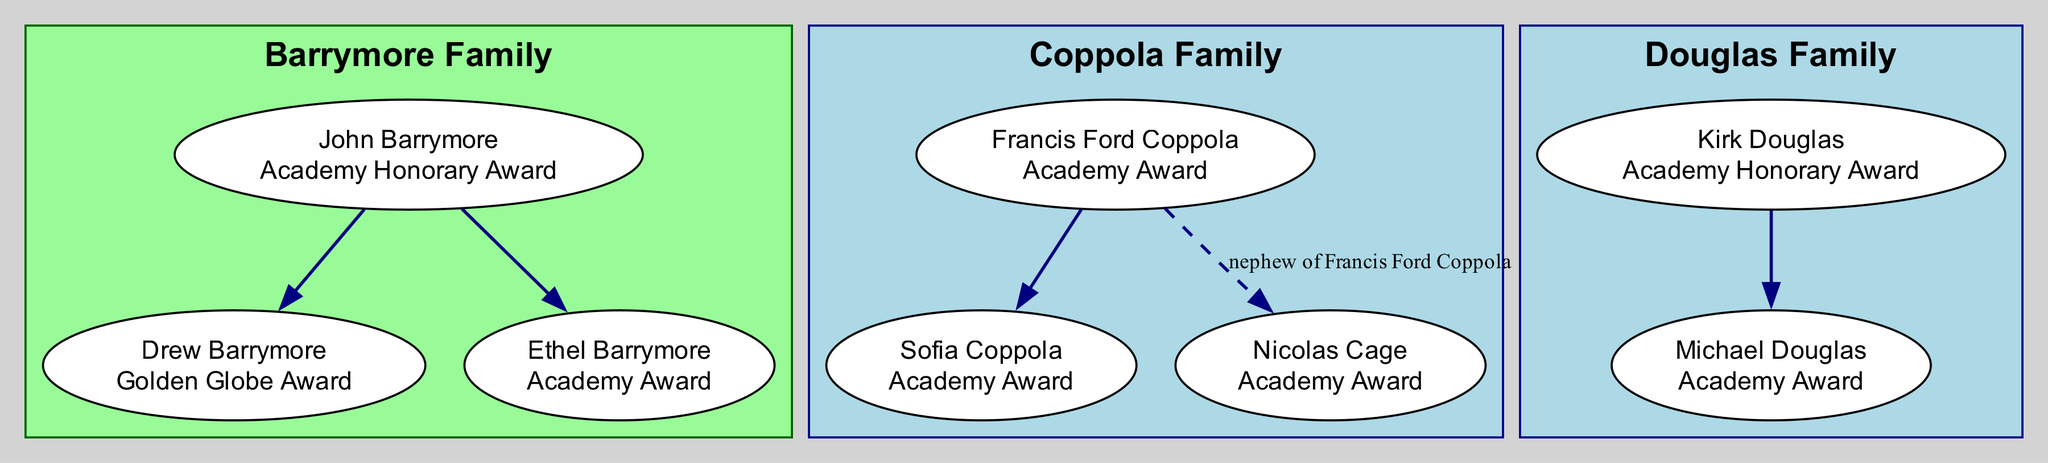What is the award of John Barrymore? The diagram shows a label for John Barrymore which indicates he received an Academy Honorary Award.
Answer: Academy Honorary Award How many generations are in the Barrymore Family? The diagram contains only one level of members under the Barrymore Family; therefore, there are three members listed on the same generation level.
Answer: 1 Who is the parent of Drew Barrymore? Looking at the diagram, it shows that Drew Barrymore is connected to John Barrymore as her parent.
Answer: John Barrymore What award has Michael Douglas received? The diagram details that Michael Douglas has been awarded an Academy Award as indicated in his label.
Answer: Academy Award How many Academy Awards are awarded in total within the Coppola Family? The diagram shows that both Francis Ford Coppola and Sofia Coppola are labeled as having received Academy Awards, which totals to two Academy Awards.
Answer: 2 Who is Nicolas Cage in relation to Francis Ford Coppola? The diagram specifies the relation between Nicolas Cage and Francis Ford Coppola as being a nephew.
Answer: nephew Which family does Ethel Barrymore belong to? The information in the diagram directly places Ethel Barrymore within the Barrymore Family.
Answer: Barrymore Family How many Academy Honorary Awards are displayed in the diagram? The diagram shows two instances of Academy Honorary Awards—one for John Barrymore and another for Kirk Douglas—thus totaling two.
Answer: 2 Is Sofia Coppola related to Nicolas Cage? The diagram illustrates that Sofia Coppola is the daughter of Francis Ford Coppola, and Nicolas Cage, being his nephew, makes Sofia his cousin.
Answer: Yes What color is used for the nodes in the Barrymore family? The diagram's nodes for the Barrymore family are filled with white color for visual clarity and contrast.
Answer: White 